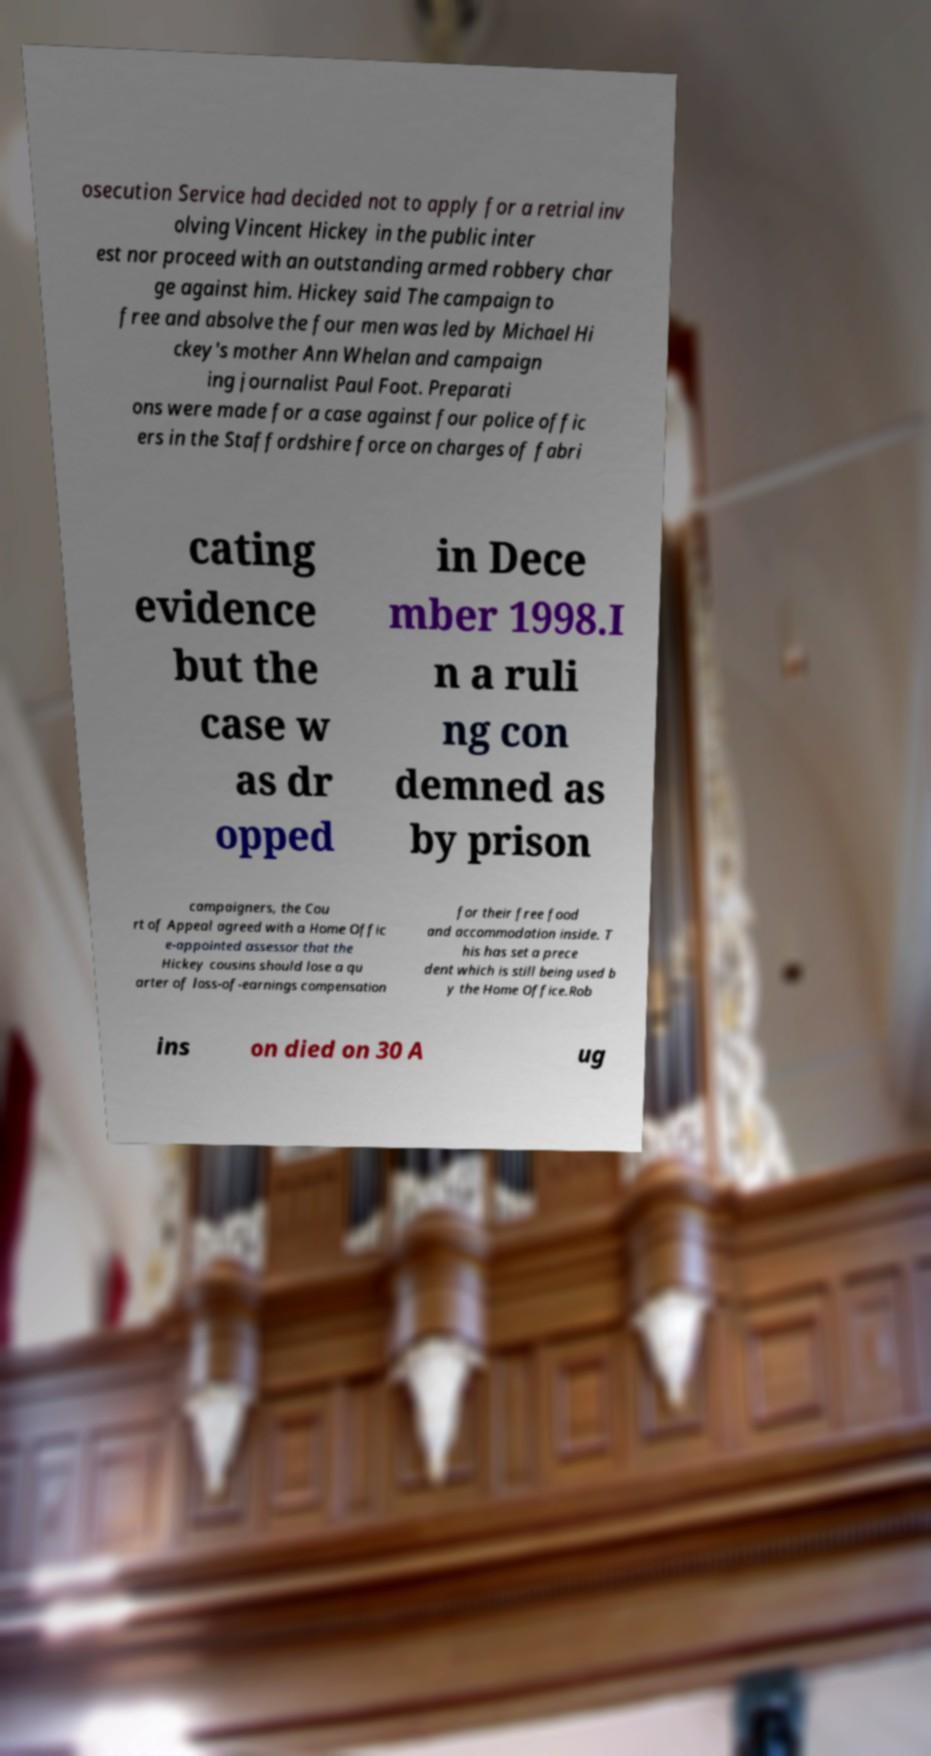Can you accurately transcribe the text from the provided image for me? osecution Service had decided not to apply for a retrial inv olving Vincent Hickey in the public inter est nor proceed with an outstanding armed robbery char ge against him. Hickey said The campaign to free and absolve the four men was led by Michael Hi ckey's mother Ann Whelan and campaign ing journalist Paul Foot. Preparati ons were made for a case against four police offic ers in the Staffordshire force on charges of fabri cating evidence but the case w as dr opped in Dece mber 1998.I n a ruli ng con demned as by prison campaigners, the Cou rt of Appeal agreed with a Home Offic e-appointed assessor that the Hickey cousins should lose a qu arter of loss-of-earnings compensation for their free food and accommodation inside. T his has set a prece dent which is still being used b y the Home Office.Rob ins on died on 30 A ug 